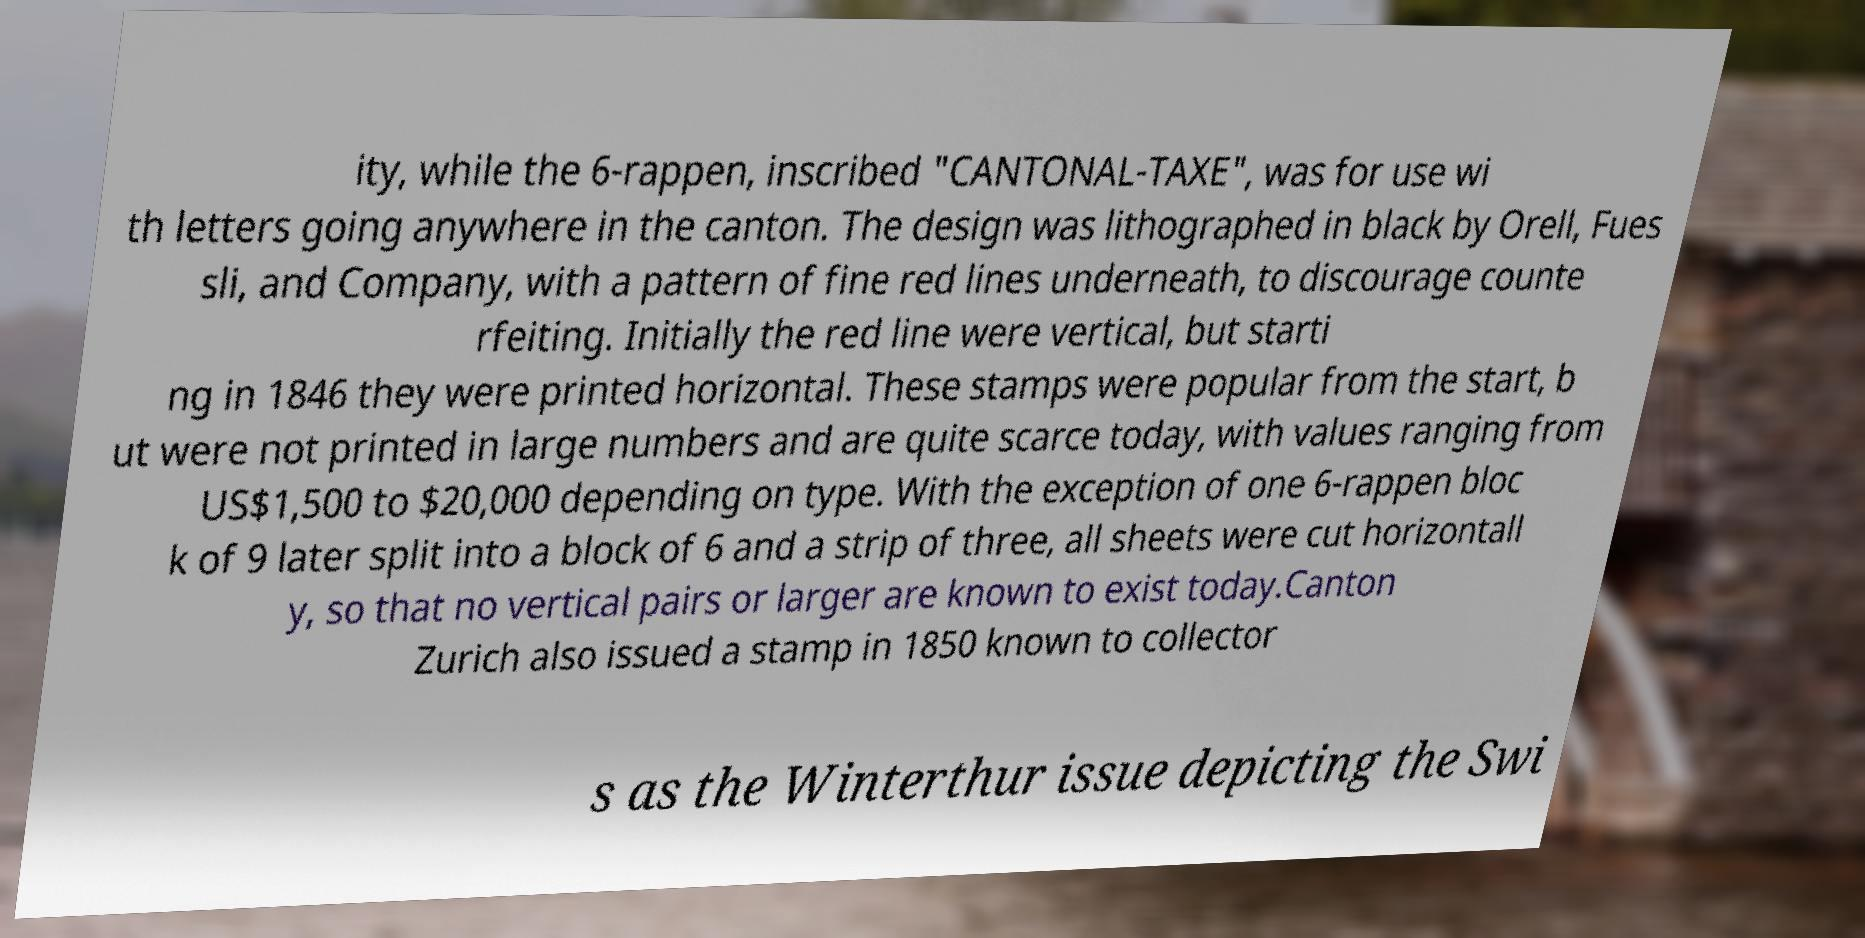Please identify and transcribe the text found in this image. ity, while the 6-rappen, inscribed "CANTONAL-TAXE", was for use wi th letters going anywhere in the canton. The design was lithographed in black by Orell, Fues sli, and Company, with a pattern of fine red lines underneath, to discourage counte rfeiting. Initially the red line were vertical, but starti ng in 1846 they were printed horizontal. These stamps were popular from the start, b ut were not printed in large numbers and are quite scarce today, with values ranging from US$1,500 to $20,000 depending on type. With the exception of one 6-rappen bloc k of 9 later split into a block of 6 and a strip of three, all sheets were cut horizontall y, so that no vertical pairs or larger are known to exist today.Canton Zurich also issued a stamp in 1850 known to collector s as the Winterthur issue depicting the Swi 